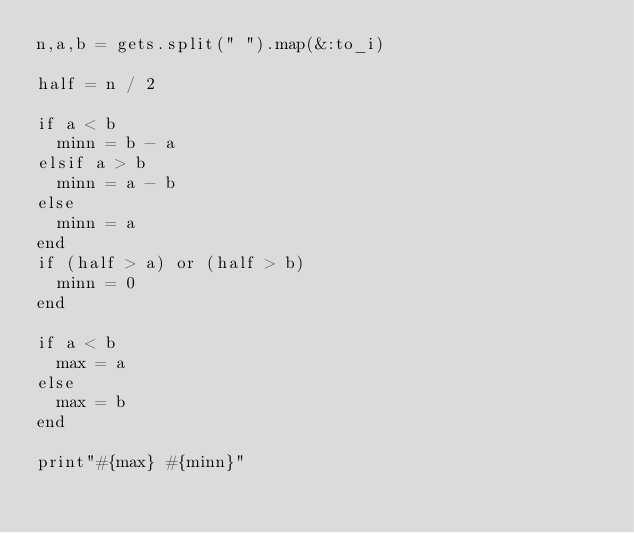<code> <loc_0><loc_0><loc_500><loc_500><_Ruby_>n,a,b = gets.split(" ").map(&:to_i)

half = n / 2

if a < b
  minn = b - a
elsif a > b
  minn = a - b
else
  minn = a
end
if (half > a) or (half > b)
  minn = 0
end

if a < b
  max = a
else
  max = b
end

print"#{max} #{minn}"</code> 